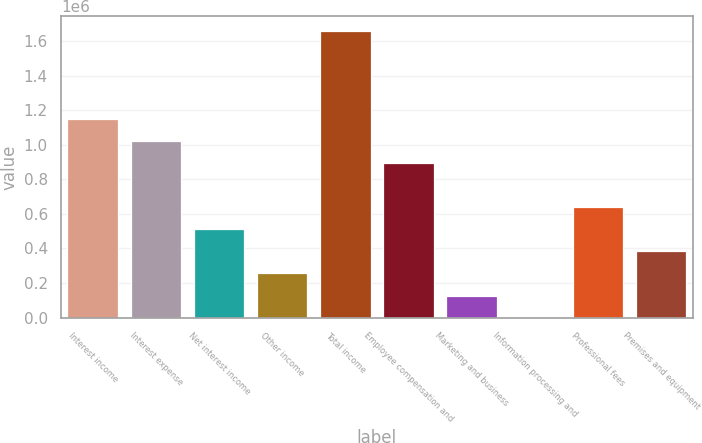<chart> <loc_0><loc_0><loc_500><loc_500><bar_chart><fcel>Interest income<fcel>Interest expense<fcel>Net interest income<fcel>Other income<fcel>Total income<fcel>Employee compensation and<fcel>Marketing and business<fcel>Information processing and<fcel>Professional fees<fcel>Premises and equipment<nl><fcel>1.14858e+06<fcel>1.02097e+06<fcel>510549<fcel>255337<fcel>1.659e+06<fcel>893367<fcel>127731<fcel>125<fcel>638155<fcel>382943<nl></chart> 